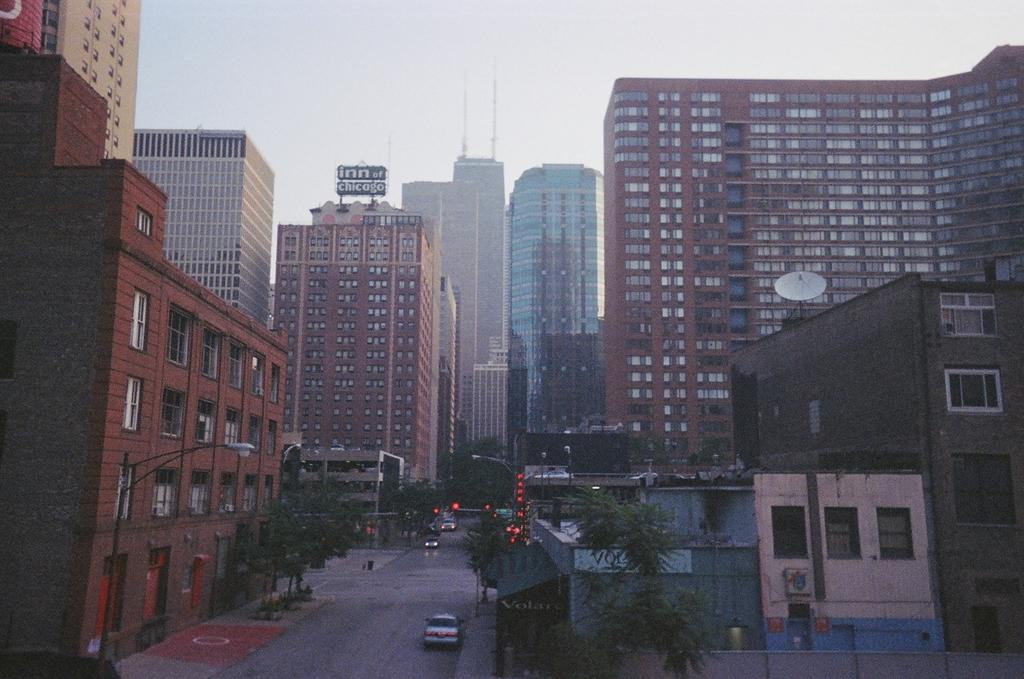What can be seen on the road in the image? There are vehicles on the road in the image. What objects are present along the road in the image? There are poles in the image. What can be seen illuminating the area in the image? There are lights in the image. What type of vegetation is visible in the image? There are trees in the image. What type of structures are visible in the image? There are buildings in the image. What is visible in the background of the image? The sky is visible in the background of the image. What type of curtain can be seen hanging in the image? There is no curtain present in the image. How many pies are visible on the table in the image? There are no pies visible in the image; it does not depict a table or any food items. 